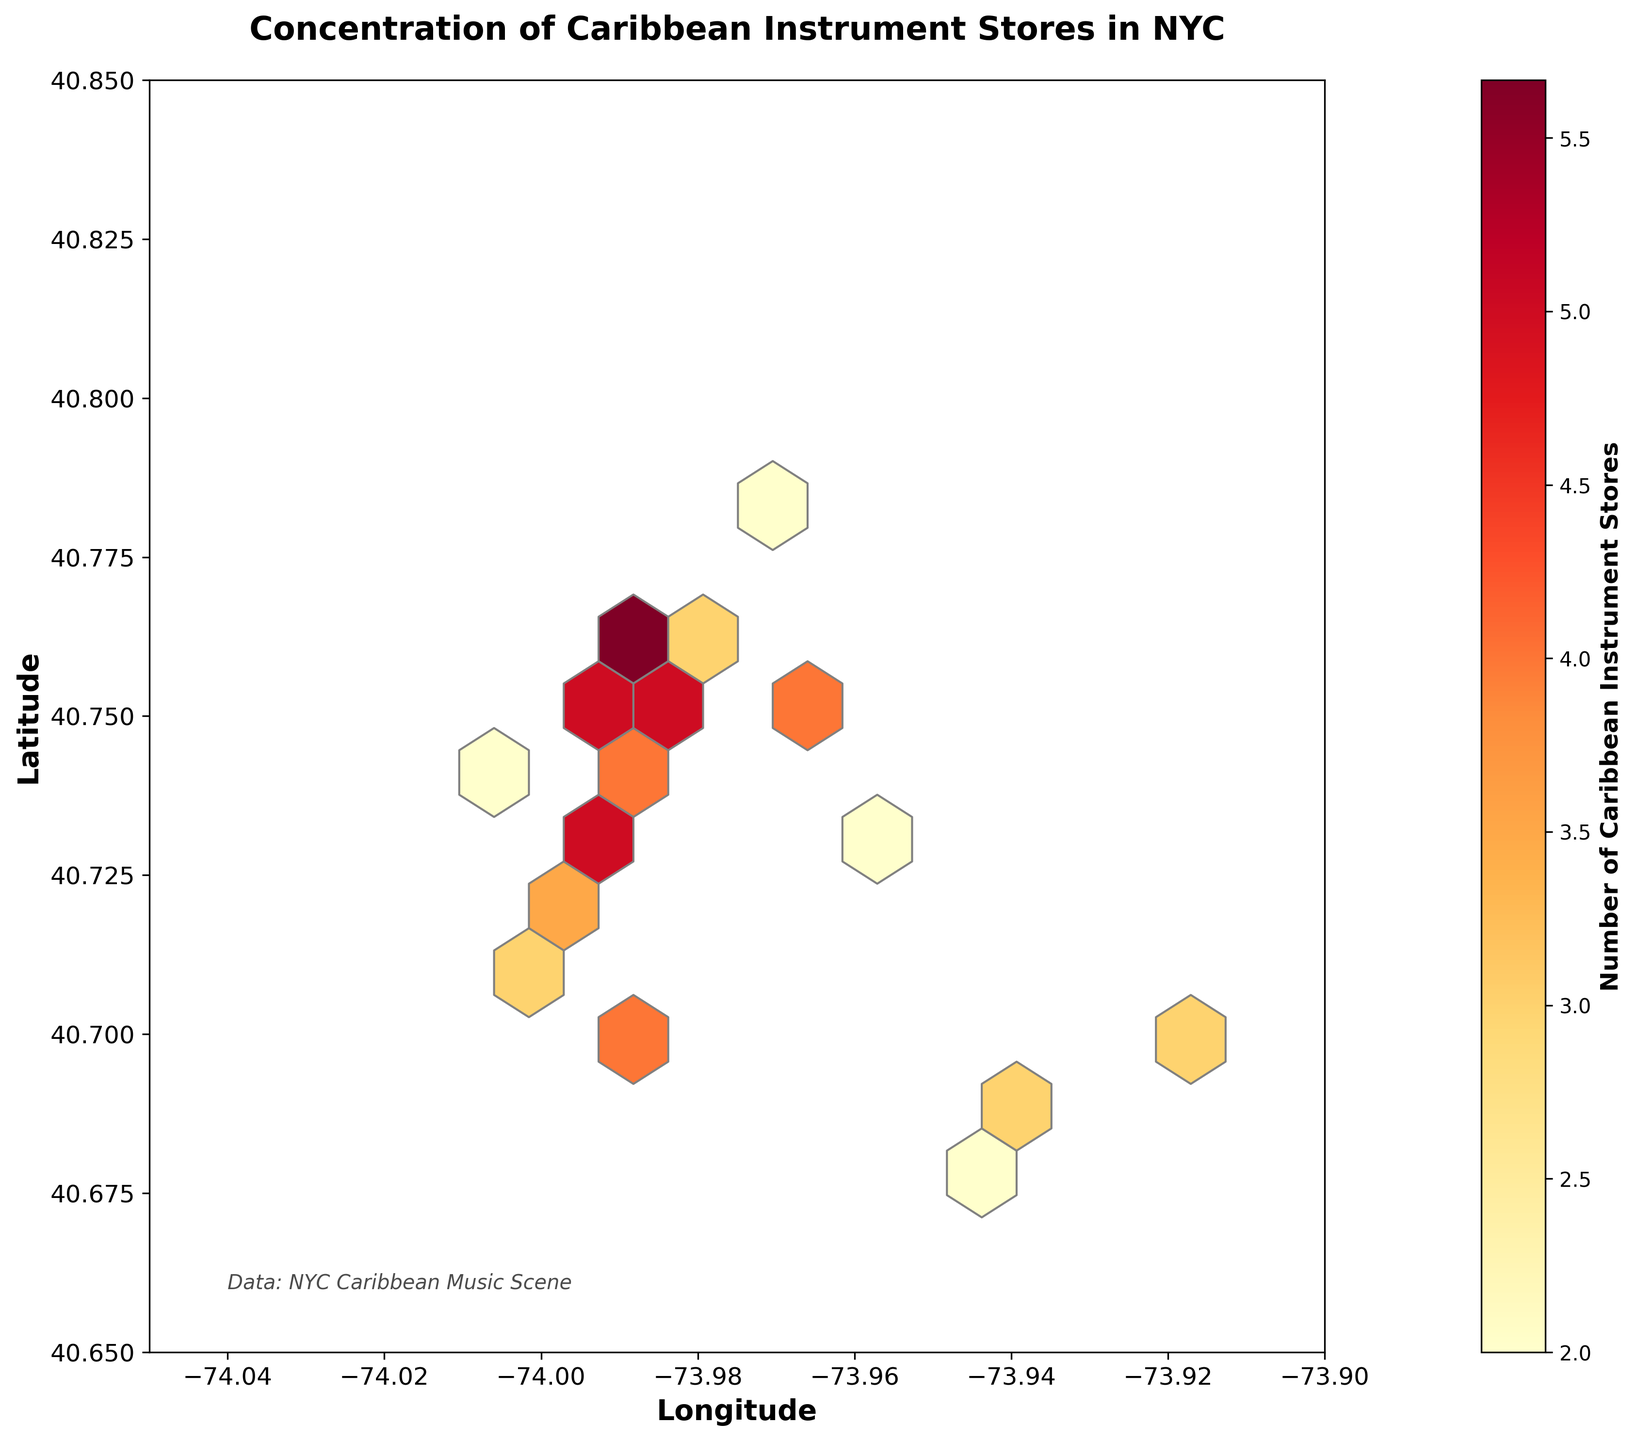What's the title of the plot? The title is prominently displayed at the top of the figure, which is common for plots to help viewers understand what the plot is about.
Answer: Concentration of Caribbean Instrument Stores in NYC What do the axes represent? The axes labels show what each axis represents. The x-axis label says "Longitude" and the y-axis label says "Latitude".
Answer: Longitude (x-axis) and Latitude (y-axis) What does the color gradient indicate? The color gradient is connected to the legend (color bar) on the side which shows the number of Caribbean Instrument stores. Different colors correspond to varying concentrations of stores.
Answer: Number of Caribbean Instrument Stores Where is the highest concentration of Caribbean instrument stores located? The hexagons colored towards the red end of the spectrum indicate highest concentration. These hexagons are found around coordinates where several data points cluster closer together with higher counts.
Answer: Around central Manhattan Compare the number of Caribbean instrument stores between central Manhattan and southern Brooklyn. By looking at the color intensity at the two locations, central Manhattan shows more red and shades of orange which indicate a higher number of stores compared to the lighter colored hexagons in southern Brooklyn.
Answer: Central Manhattan has more stores Which area has the least concentration of Caribbean instrument stores? The area with the hexagons in lighter colors, closer to yellow, signifies fewer stores. This can be seen around parts of Brooklyn and the vicinity of waters.
Answer: Brooklyn How many stores are represented by the darkest hexagons? The color bar indicates the number of stores for each color. By finding the darkest color on the color bar, you can see it corresponds to 6 stores.
Answer: 6 stores What coordinates approximate the boundary limits of the plot? The figure provides axis scales which show that the x-axis extends roughly from -74.05 to -73.90 and the y-axis spans from 40.65 to 40.85.
Answer: Longitude: -74.05 to -73.90, Latitude: 40.65 to 40.85 What's the range of the number of Caribbean instrument stores across the plot? Check the labels on the color bar, it ranges from the minimum to maximum values represented by different colors. The range visible is from 2 to 6 stores.
Answer: From 2 to 6 stores 